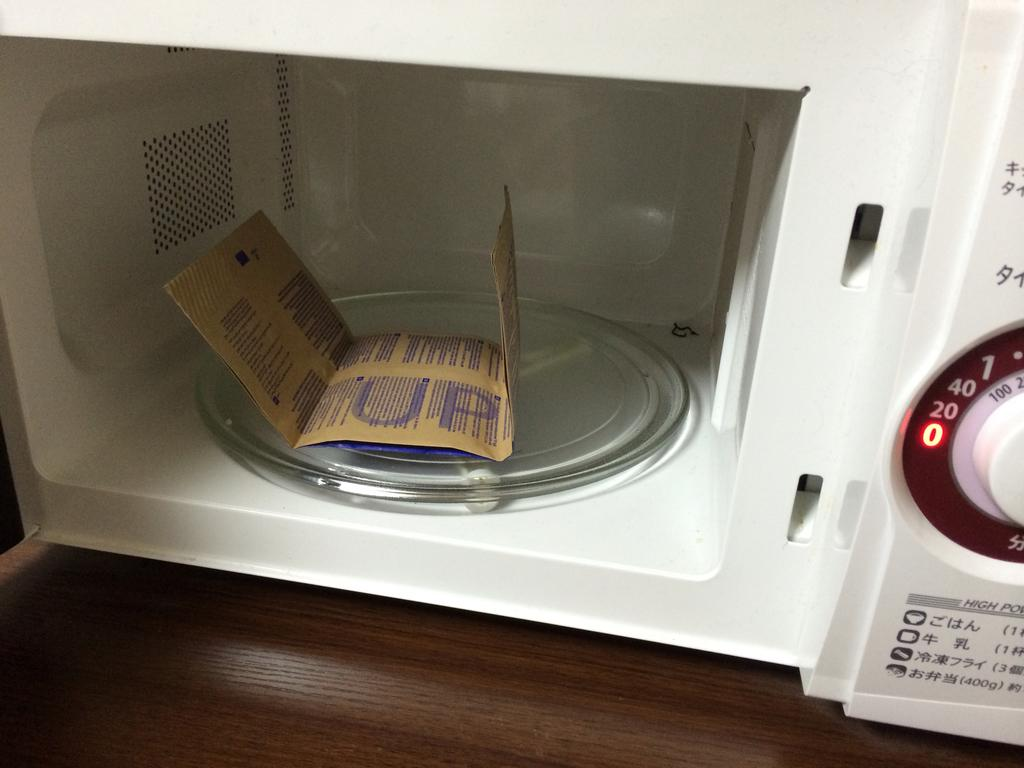Provide a one-sentence caption for the provided image. A packet of food is sitting in a microwave that is current at Zero. 